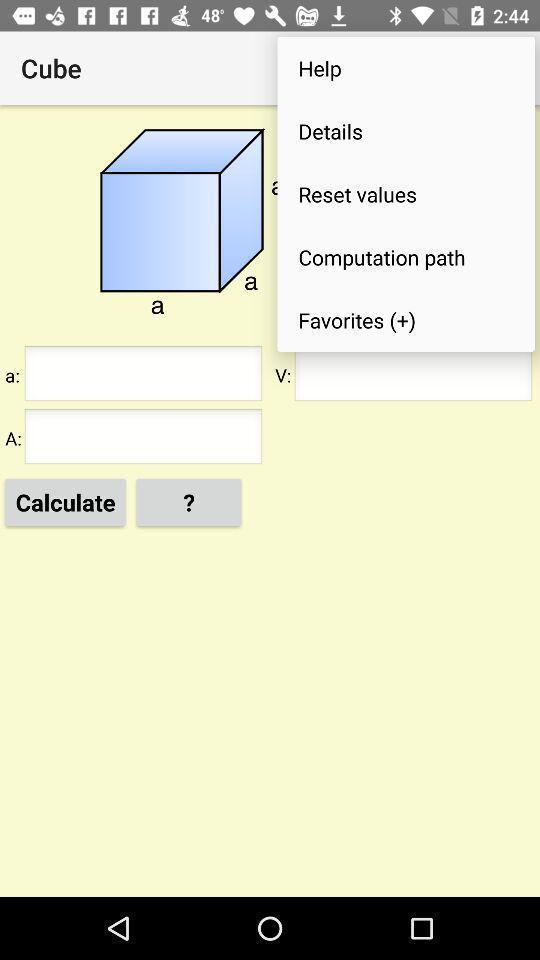Describe the visual elements of this screenshot. Page showing different options on a learning app. 